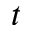<formula> <loc_0><loc_0><loc_500><loc_500>t</formula> 